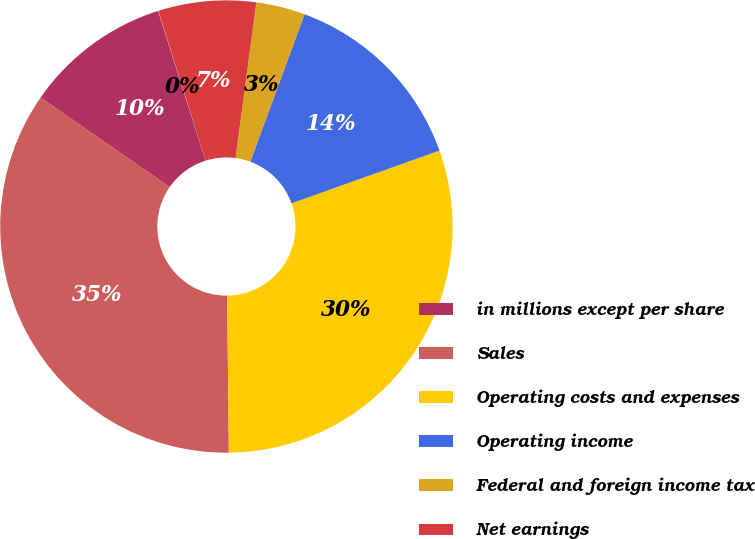Convert chart to OTSL. <chart><loc_0><loc_0><loc_500><loc_500><pie_chart><fcel>in millions except per share<fcel>Sales<fcel>Operating costs and expenses<fcel>Operating income<fcel>Federal and foreign income tax<fcel>Net earnings<fcel>Diluted earnings per share<nl><fcel>10.46%<fcel>34.83%<fcel>30.28%<fcel>13.94%<fcel>3.5%<fcel>6.98%<fcel>0.02%<nl></chart> 